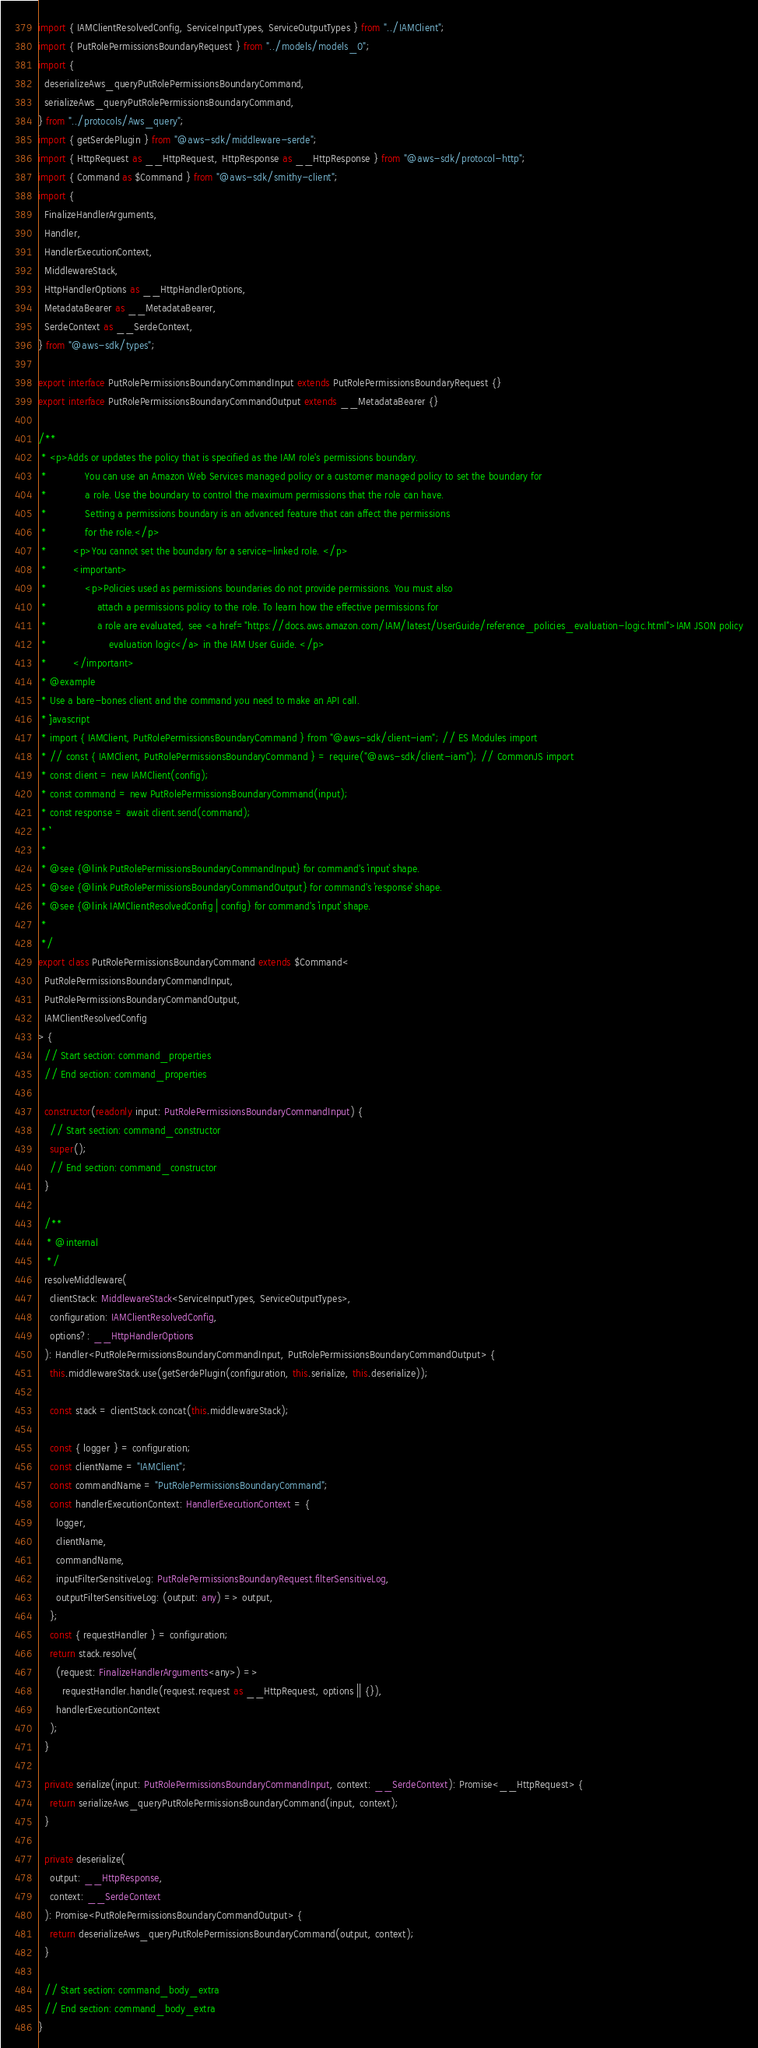Convert code to text. <code><loc_0><loc_0><loc_500><loc_500><_TypeScript_>import { IAMClientResolvedConfig, ServiceInputTypes, ServiceOutputTypes } from "../IAMClient";
import { PutRolePermissionsBoundaryRequest } from "../models/models_0";
import {
  deserializeAws_queryPutRolePermissionsBoundaryCommand,
  serializeAws_queryPutRolePermissionsBoundaryCommand,
} from "../protocols/Aws_query";
import { getSerdePlugin } from "@aws-sdk/middleware-serde";
import { HttpRequest as __HttpRequest, HttpResponse as __HttpResponse } from "@aws-sdk/protocol-http";
import { Command as $Command } from "@aws-sdk/smithy-client";
import {
  FinalizeHandlerArguments,
  Handler,
  HandlerExecutionContext,
  MiddlewareStack,
  HttpHandlerOptions as __HttpHandlerOptions,
  MetadataBearer as __MetadataBearer,
  SerdeContext as __SerdeContext,
} from "@aws-sdk/types";

export interface PutRolePermissionsBoundaryCommandInput extends PutRolePermissionsBoundaryRequest {}
export interface PutRolePermissionsBoundaryCommandOutput extends __MetadataBearer {}

/**
 * <p>Adds or updates the policy that is specified as the IAM role's permissions boundary.
 *             You can use an Amazon Web Services managed policy or a customer managed policy to set the boundary for
 *             a role. Use the boundary to control the maximum permissions that the role can have.
 *             Setting a permissions boundary is an advanced feature that can affect the permissions
 *             for the role.</p>
 *         <p>You cannot set the boundary for a service-linked role. </p>
 *         <important>
 *             <p>Policies used as permissions boundaries do not provide permissions. You must also
 *                 attach a permissions policy to the role. To learn how the effective permissions for
 *                 a role are evaluated, see <a href="https://docs.aws.amazon.com/IAM/latest/UserGuide/reference_policies_evaluation-logic.html">IAM JSON policy
 *                     evaluation logic</a> in the IAM User Guide. </p>
 *         </important>
 * @example
 * Use a bare-bones client and the command you need to make an API call.
 * ```javascript
 * import { IAMClient, PutRolePermissionsBoundaryCommand } from "@aws-sdk/client-iam"; // ES Modules import
 * // const { IAMClient, PutRolePermissionsBoundaryCommand } = require("@aws-sdk/client-iam"); // CommonJS import
 * const client = new IAMClient(config);
 * const command = new PutRolePermissionsBoundaryCommand(input);
 * const response = await client.send(command);
 * ```
 *
 * @see {@link PutRolePermissionsBoundaryCommandInput} for command's `input` shape.
 * @see {@link PutRolePermissionsBoundaryCommandOutput} for command's `response` shape.
 * @see {@link IAMClientResolvedConfig | config} for command's `input` shape.
 *
 */
export class PutRolePermissionsBoundaryCommand extends $Command<
  PutRolePermissionsBoundaryCommandInput,
  PutRolePermissionsBoundaryCommandOutput,
  IAMClientResolvedConfig
> {
  // Start section: command_properties
  // End section: command_properties

  constructor(readonly input: PutRolePermissionsBoundaryCommandInput) {
    // Start section: command_constructor
    super();
    // End section: command_constructor
  }

  /**
   * @internal
   */
  resolveMiddleware(
    clientStack: MiddlewareStack<ServiceInputTypes, ServiceOutputTypes>,
    configuration: IAMClientResolvedConfig,
    options?: __HttpHandlerOptions
  ): Handler<PutRolePermissionsBoundaryCommandInput, PutRolePermissionsBoundaryCommandOutput> {
    this.middlewareStack.use(getSerdePlugin(configuration, this.serialize, this.deserialize));

    const stack = clientStack.concat(this.middlewareStack);

    const { logger } = configuration;
    const clientName = "IAMClient";
    const commandName = "PutRolePermissionsBoundaryCommand";
    const handlerExecutionContext: HandlerExecutionContext = {
      logger,
      clientName,
      commandName,
      inputFilterSensitiveLog: PutRolePermissionsBoundaryRequest.filterSensitiveLog,
      outputFilterSensitiveLog: (output: any) => output,
    };
    const { requestHandler } = configuration;
    return stack.resolve(
      (request: FinalizeHandlerArguments<any>) =>
        requestHandler.handle(request.request as __HttpRequest, options || {}),
      handlerExecutionContext
    );
  }

  private serialize(input: PutRolePermissionsBoundaryCommandInput, context: __SerdeContext): Promise<__HttpRequest> {
    return serializeAws_queryPutRolePermissionsBoundaryCommand(input, context);
  }

  private deserialize(
    output: __HttpResponse,
    context: __SerdeContext
  ): Promise<PutRolePermissionsBoundaryCommandOutput> {
    return deserializeAws_queryPutRolePermissionsBoundaryCommand(output, context);
  }

  // Start section: command_body_extra
  // End section: command_body_extra
}
</code> 